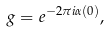<formula> <loc_0><loc_0><loc_500><loc_500>g = e ^ { - 2 \pi i \alpha ( 0 ) } ,</formula> 